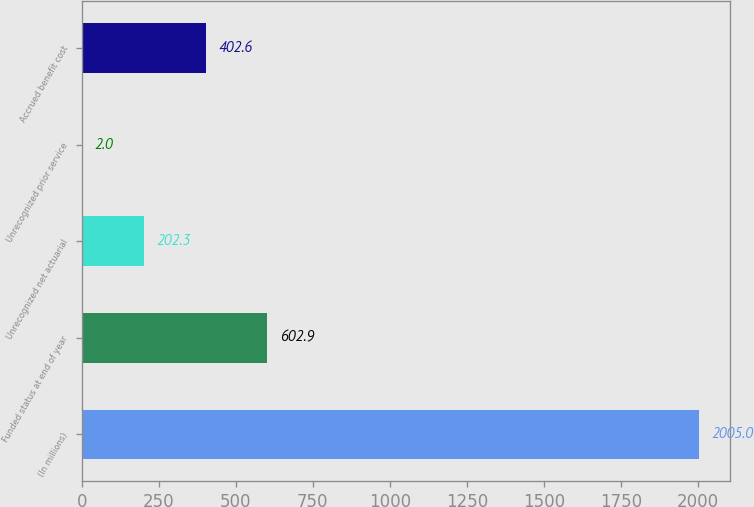<chart> <loc_0><loc_0><loc_500><loc_500><bar_chart><fcel>(In millions)<fcel>Funded status at end of year<fcel>Unrecognized net actuarial<fcel>Unrecognized prior service<fcel>Accrued benefit cost<nl><fcel>2005<fcel>602.9<fcel>202.3<fcel>2<fcel>402.6<nl></chart> 